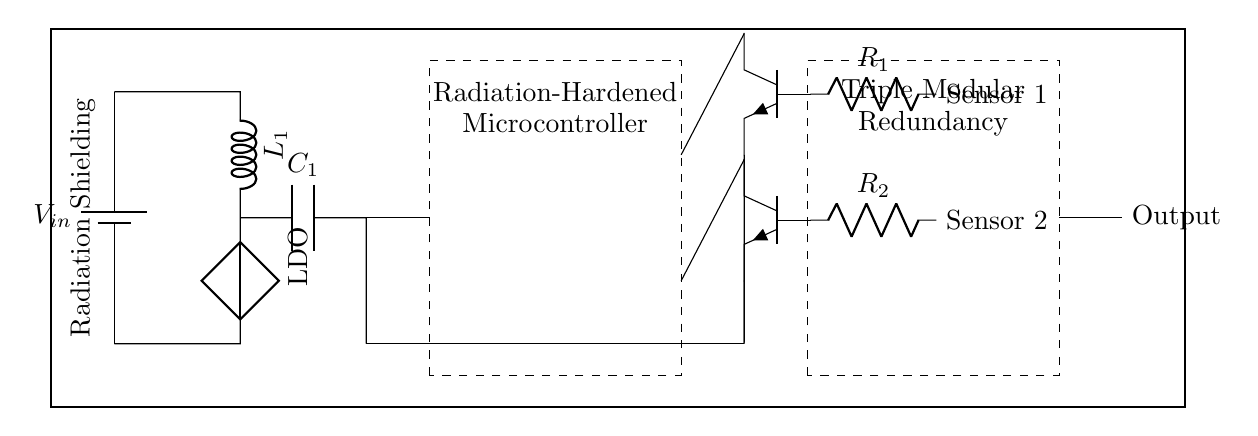What is the input voltage of the circuit? The circuit diagram indicates a battery symbol labeled V_in, which represents the input voltage. This is the primary source of power for the circuit.
Answer: V_in What type of voltage regulator is depicted in the circuit? The circuit shows a cute inductor followed by a component labeled LDO, indicating that this is a Low Dropout Regulator, designed for efficient voltage regulation across varying loads.
Answer: Low Dropout Regulator How many sensors are present in the circuit? The circuit diagram features two sensor components connected to resistors, indicating that there are two sensors utilized in the design.
Answer: 2 What is the purpose of the shielding indicated in the circuit? The thick rectangle drawn around the entire circuit diagram is labeled Radiation Shielding, which serves the purpose of protecting the internal components from cosmic radiation during space exploration.
Answer: Radiation Shielding What does Triple Modular Redundancy refer to in this circuit? In the circuit, Triple Modular Redundancy is represented by a dashed rectangle labeled as such, and this concept involves using three processing units to improve reliability and fault tolerance in the microcontroller's operations.
Answer: Fault tolerance 